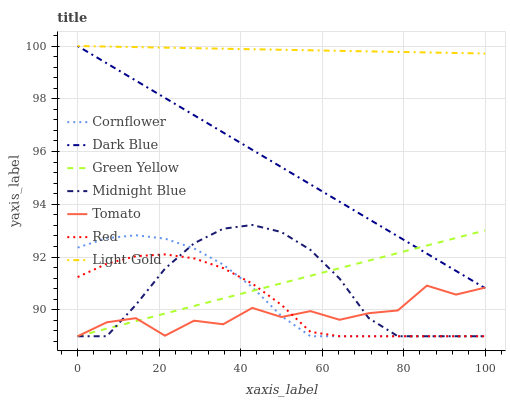Does Tomato have the minimum area under the curve?
Answer yes or no. Yes. Does Light Gold have the maximum area under the curve?
Answer yes or no. Yes. Does Cornflower have the minimum area under the curve?
Answer yes or no. No. Does Cornflower have the maximum area under the curve?
Answer yes or no. No. Is Green Yellow the smoothest?
Answer yes or no. Yes. Is Tomato the roughest?
Answer yes or no. Yes. Is Cornflower the smoothest?
Answer yes or no. No. Is Cornflower the roughest?
Answer yes or no. No. Does Tomato have the lowest value?
Answer yes or no. Yes. Does Dark Blue have the lowest value?
Answer yes or no. No. Does Light Gold have the highest value?
Answer yes or no. Yes. Does Cornflower have the highest value?
Answer yes or no. No. Is Red less than Light Gold?
Answer yes or no. Yes. Is Dark Blue greater than Red?
Answer yes or no. Yes. Does Midnight Blue intersect Tomato?
Answer yes or no. Yes. Is Midnight Blue less than Tomato?
Answer yes or no. No. Is Midnight Blue greater than Tomato?
Answer yes or no. No. Does Red intersect Light Gold?
Answer yes or no. No. 